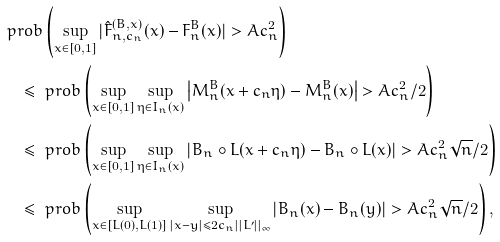<formula> <loc_0><loc_0><loc_500><loc_500>& \ p r o b \left ( \sup _ { x \in [ 0 , 1 ] } | \hat { F } _ { n , c _ { n } } ^ { ( B , x ) } ( x ) - F _ { n } ^ { B } ( x ) | > A c _ { n } ^ { 2 } \right ) \\ & \quad \leq \ p r o b \left ( \sup _ { x \in [ 0 , 1 ] } \sup _ { \eta \in I _ { n } ( x ) } \left | M _ { n } ^ { B } ( x + c _ { n } \eta ) - M _ { n } ^ { B } ( x ) \right | > A c _ { n } ^ { 2 } / 2 \right ) \\ & \quad \leq \ p r o b \left ( \sup _ { x \in [ 0 , 1 ] } \sup _ { \eta \in I _ { n } ( x ) } \left | B _ { n } \circ L ( x + c _ { n } \eta ) - B _ { n } \circ L ( x ) \right | > A c _ { n } ^ { 2 } \sqrt { n } / 2 \right ) \\ & \quad \leq \ p r o b \left ( \sup _ { x \in [ L ( 0 ) , L ( 1 ) ] } \sup _ { | x - y | \leq 2 c _ { n } | | L ^ { \prime } | | _ { \infty } } \left | B _ { n } ( x ) - B _ { n } ( y ) \right | > A c _ { n } ^ { 2 } \sqrt { n } / 2 \right ) ,</formula> 